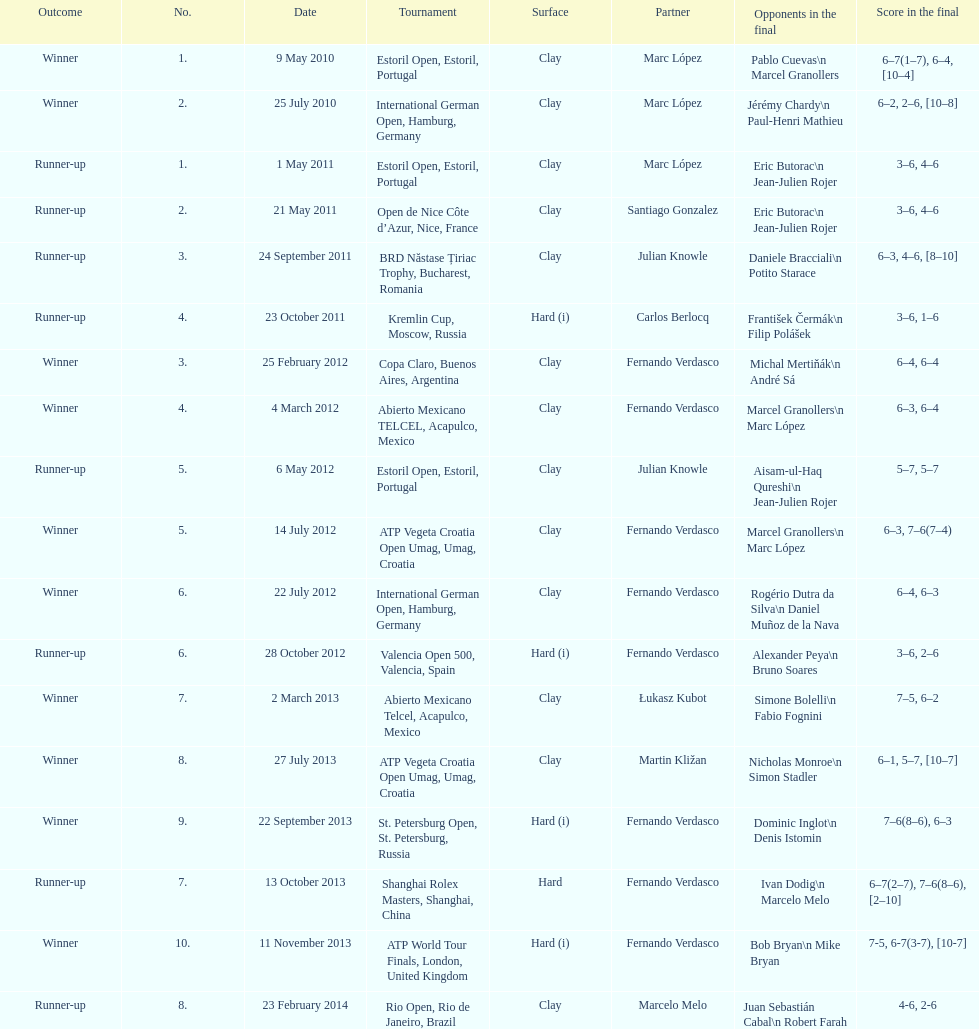What tournament was before the estoril open? Abierto Mexicano TELCEL, Acapulco, Mexico. 